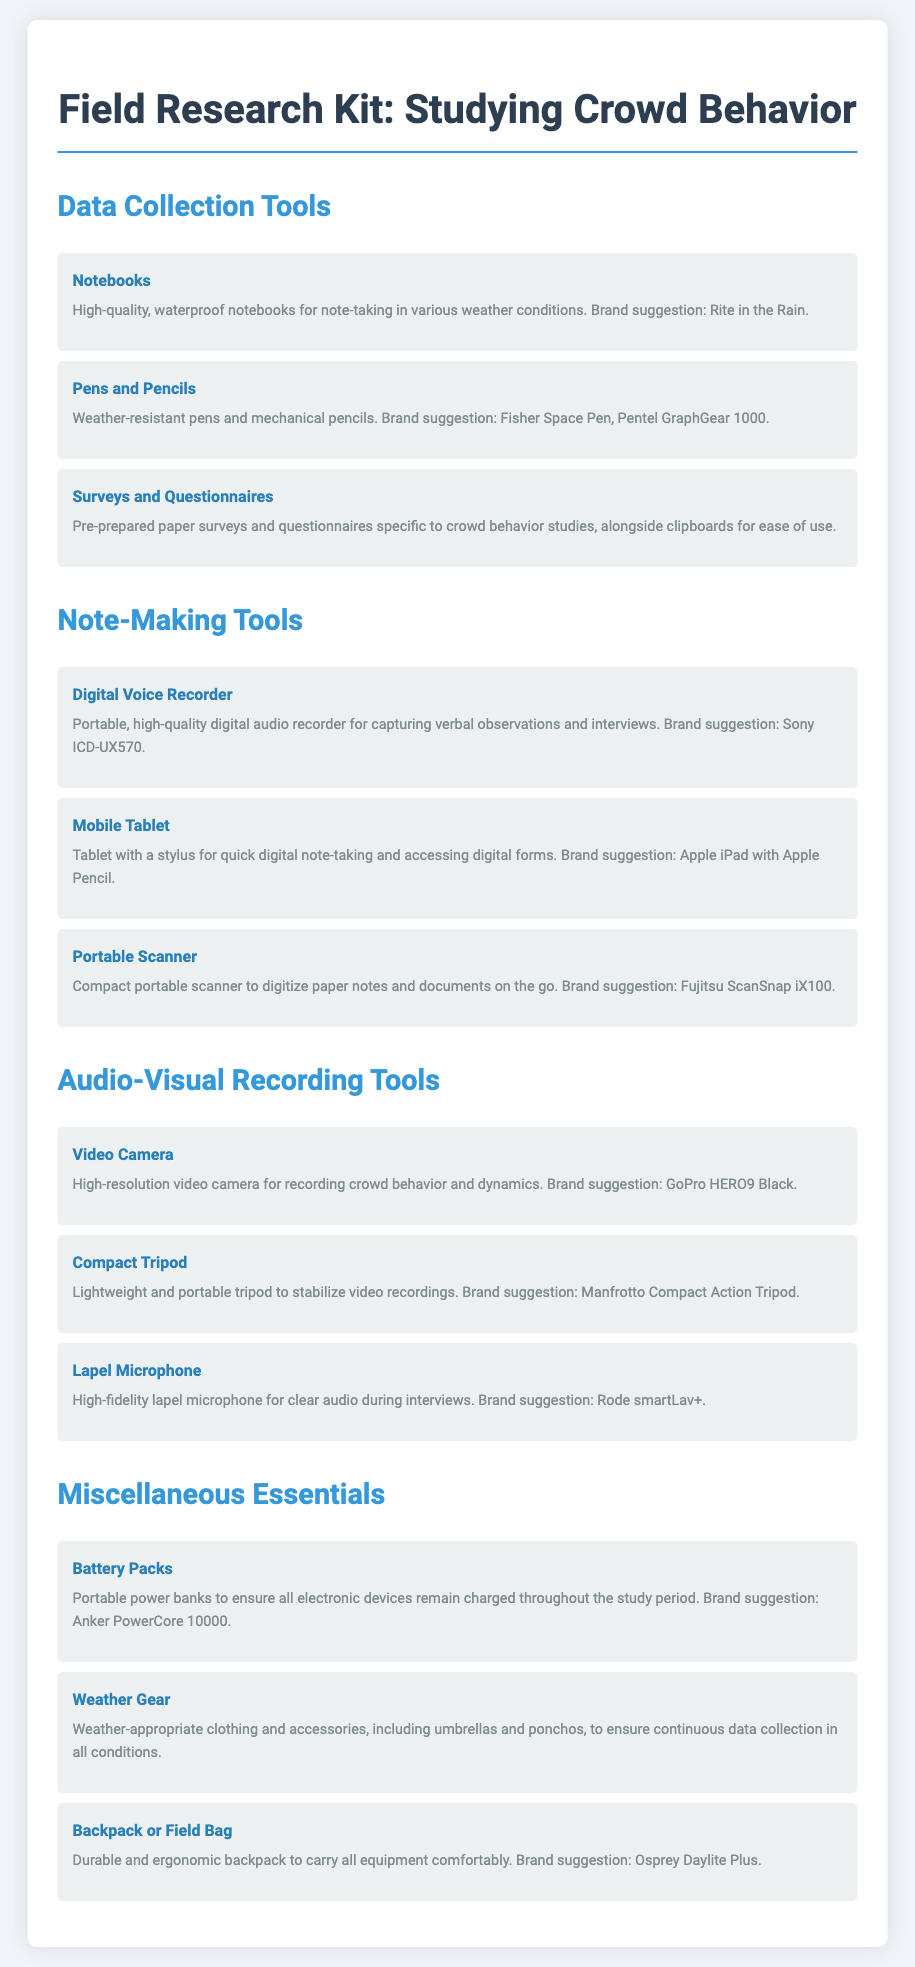What is suggested for waterproof notebooks? The document suggests using Rite in the Rain for waterproof notebooks.
Answer: Rite in the Rain Which brand is suggested for the digital voice recorder? The document specifies Sony ICD-UX570 as the brand for the digital voice recorder.
Answer: Sony ICD-UX570 How many types of tools are listed under "Audio-Visual Recording Tools"? The document lists three tools under "Audio-Visual Recording Tools": video camera, compact tripod, and lapel microphone.
Answer: 3 What should you carry your equipment in? The document recommends using a durable and ergonomic backpack or field bag.
Answer: Backpack or Field Bag What is a suggested brand for battery packs? The document mentions Anker PowerCore 10000 as a brand for battery packs.
Answer: Anker PowerCore 10000 Why are weather gear items included in the kit? Weather gear is included to ensure continuous data collection in all conditions.
Answer: Continuous data collection What type of microphone is recommended for clear audio? The document recommends a high-fidelity lapel microphone for clear audio.
Answer: Lapel Microphone What is suggested for quick digital note-taking? The document suggests using a mobile tablet with a stylus for quick digital note-taking.
Answer: Mobile Tablet 